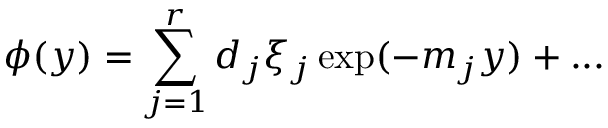Convert formula to latex. <formula><loc_0><loc_0><loc_500><loc_500>\phi ( y ) = \sum _ { j = 1 } ^ { r } d _ { j } \xi _ { j } \exp ( - m _ { j } y ) + \dots</formula> 